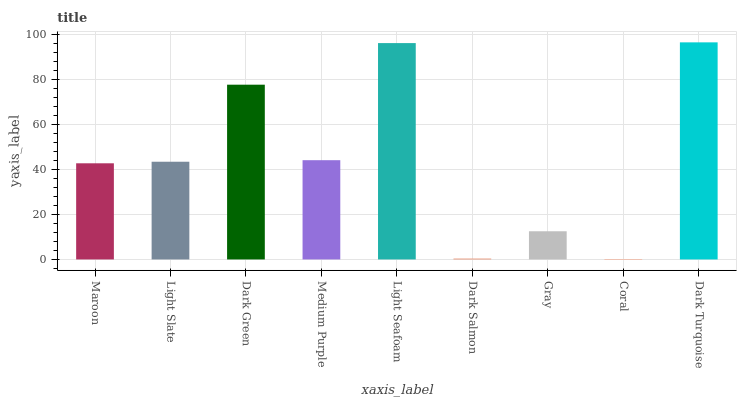Is Coral the minimum?
Answer yes or no. Yes. Is Dark Turquoise the maximum?
Answer yes or no. Yes. Is Light Slate the minimum?
Answer yes or no. No. Is Light Slate the maximum?
Answer yes or no. No. Is Light Slate greater than Maroon?
Answer yes or no. Yes. Is Maroon less than Light Slate?
Answer yes or no. Yes. Is Maroon greater than Light Slate?
Answer yes or no. No. Is Light Slate less than Maroon?
Answer yes or no. No. Is Light Slate the high median?
Answer yes or no. Yes. Is Light Slate the low median?
Answer yes or no. Yes. Is Medium Purple the high median?
Answer yes or no. No. Is Maroon the low median?
Answer yes or no. No. 